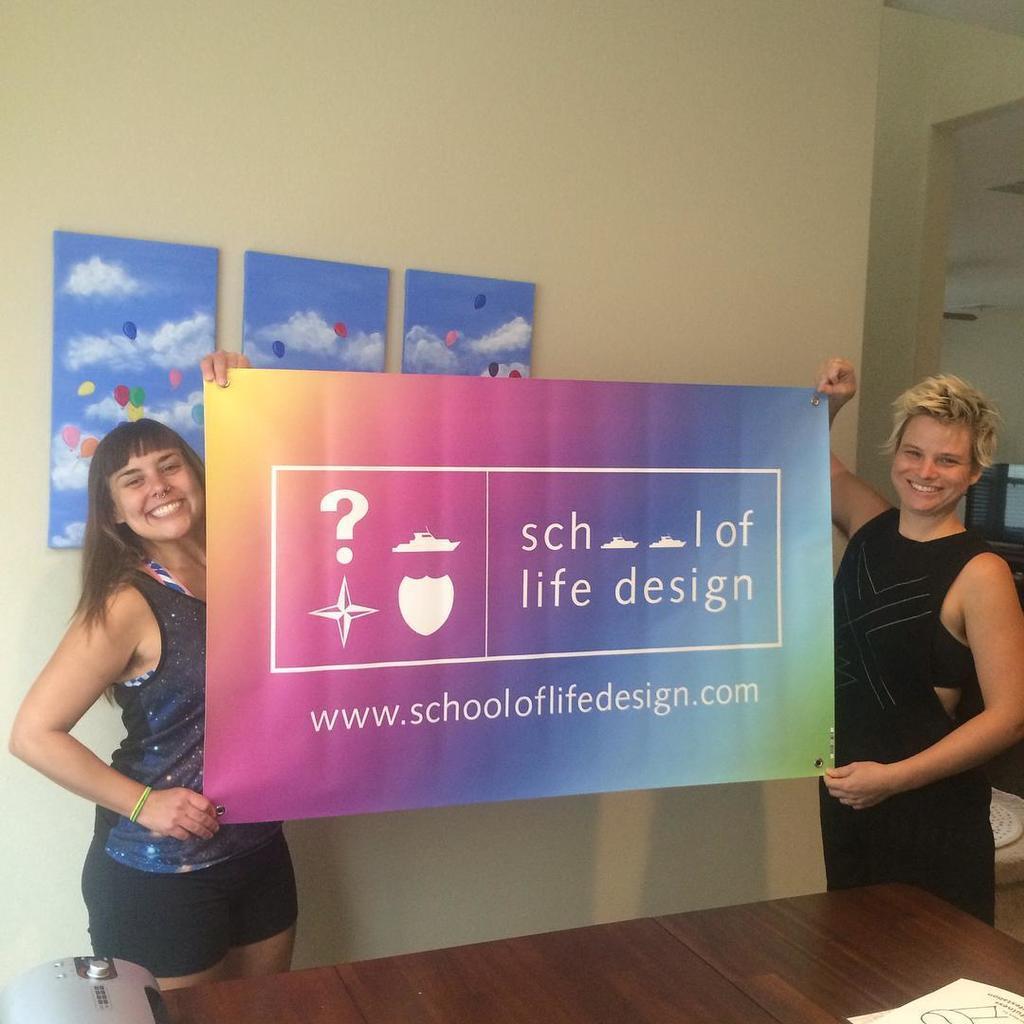Can you describe this image briefly? In this image I can see two people are holding colorful broad. In front I can see few objects on the table and few frames are attached to the wall. 